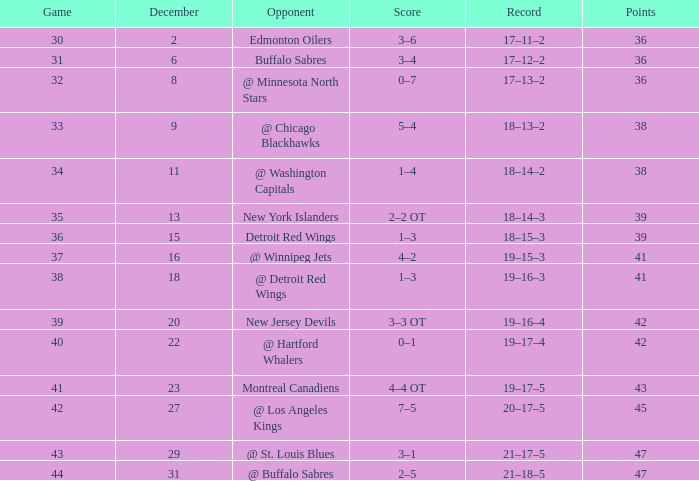After december 29 what is the score? 2–5. 